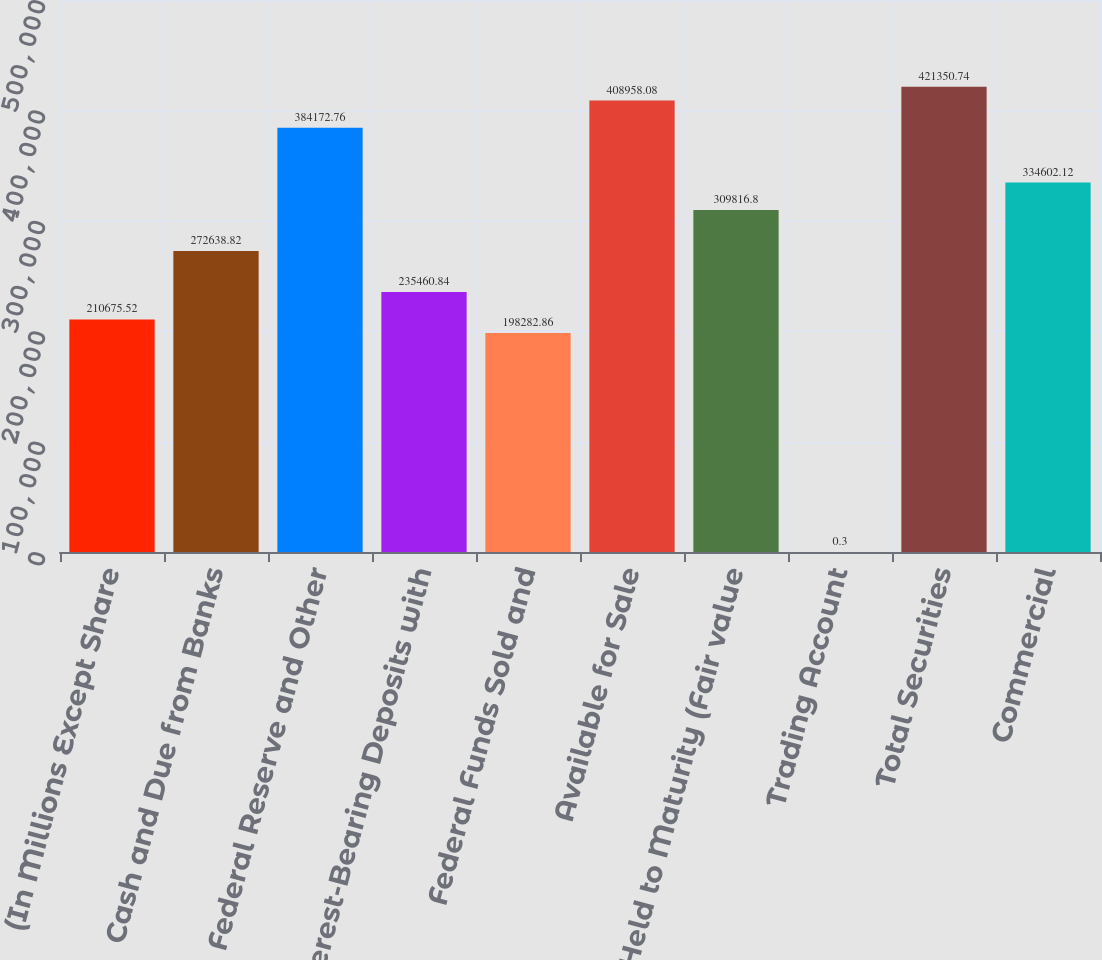<chart> <loc_0><loc_0><loc_500><loc_500><bar_chart><fcel>(In Millions Except Share<fcel>Cash and Due from Banks<fcel>Federal Reserve and Other<fcel>Interest-Bearing Deposits with<fcel>Federal Funds Sold and<fcel>Available for Sale<fcel>Held to Maturity (Fair value<fcel>Trading Account<fcel>Total Securities<fcel>Commercial<nl><fcel>210676<fcel>272639<fcel>384173<fcel>235461<fcel>198283<fcel>408958<fcel>309817<fcel>0.3<fcel>421351<fcel>334602<nl></chart> 